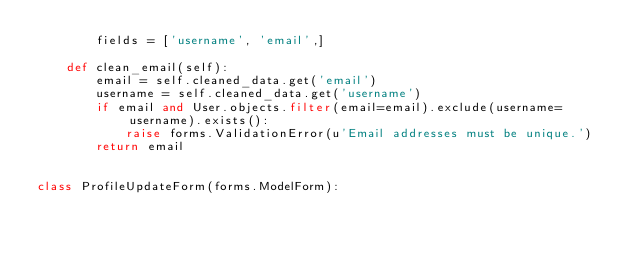Convert code to text. <code><loc_0><loc_0><loc_500><loc_500><_Python_>        fields = ['username', 'email',]
    
    def clean_email(self):
        email = self.cleaned_data.get('email')
        username = self.cleaned_data.get('username')
        if email and User.objects.filter(email=email).exclude(username=username).exists():
            raise forms.ValidationError(u'Email addresses must be unique.')
        return email


class ProfileUpdateForm(forms.ModelForm):</code> 